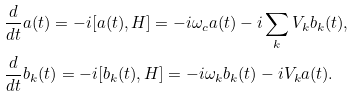<formula> <loc_0><loc_0><loc_500><loc_500>& \frac { d } { d t } a ( t ) = - i [ a ( t ) , H ] = - i \omega _ { c } a ( t ) - i \sum _ { k } V _ { k } b _ { k } ( t ) , \\ & \frac { d } { d t } b _ { k } ( t ) = - i [ b _ { k } ( t ) , H ] = - i \omega _ { k } b _ { k } ( t ) - i V _ { k } a ( t ) .</formula> 